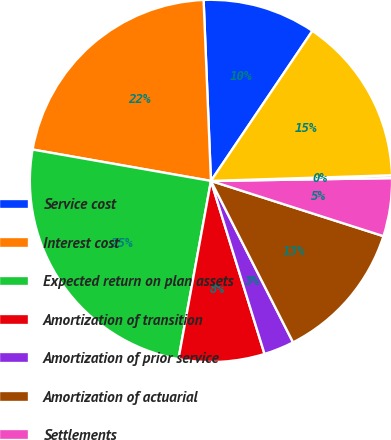<chart> <loc_0><loc_0><loc_500><loc_500><pie_chart><fcel>Service cost<fcel>Interest cost<fcel>Expected return on plan assets<fcel>Amortization of transition<fcel>Amortization of prior service<fcel>Amortization of actuarial<fcel>Settlements<fcel>Special termination<fcel>Net periodic (benefit) cost<nl><fcel>10.11%<fcel>21.58%<fcel>24.9%<fcel>7.65%<fcel>2.71%<fcel>12.58%<fcel>5.18%<fcel>0.25%<fcel>15.04%<nl></chart> 